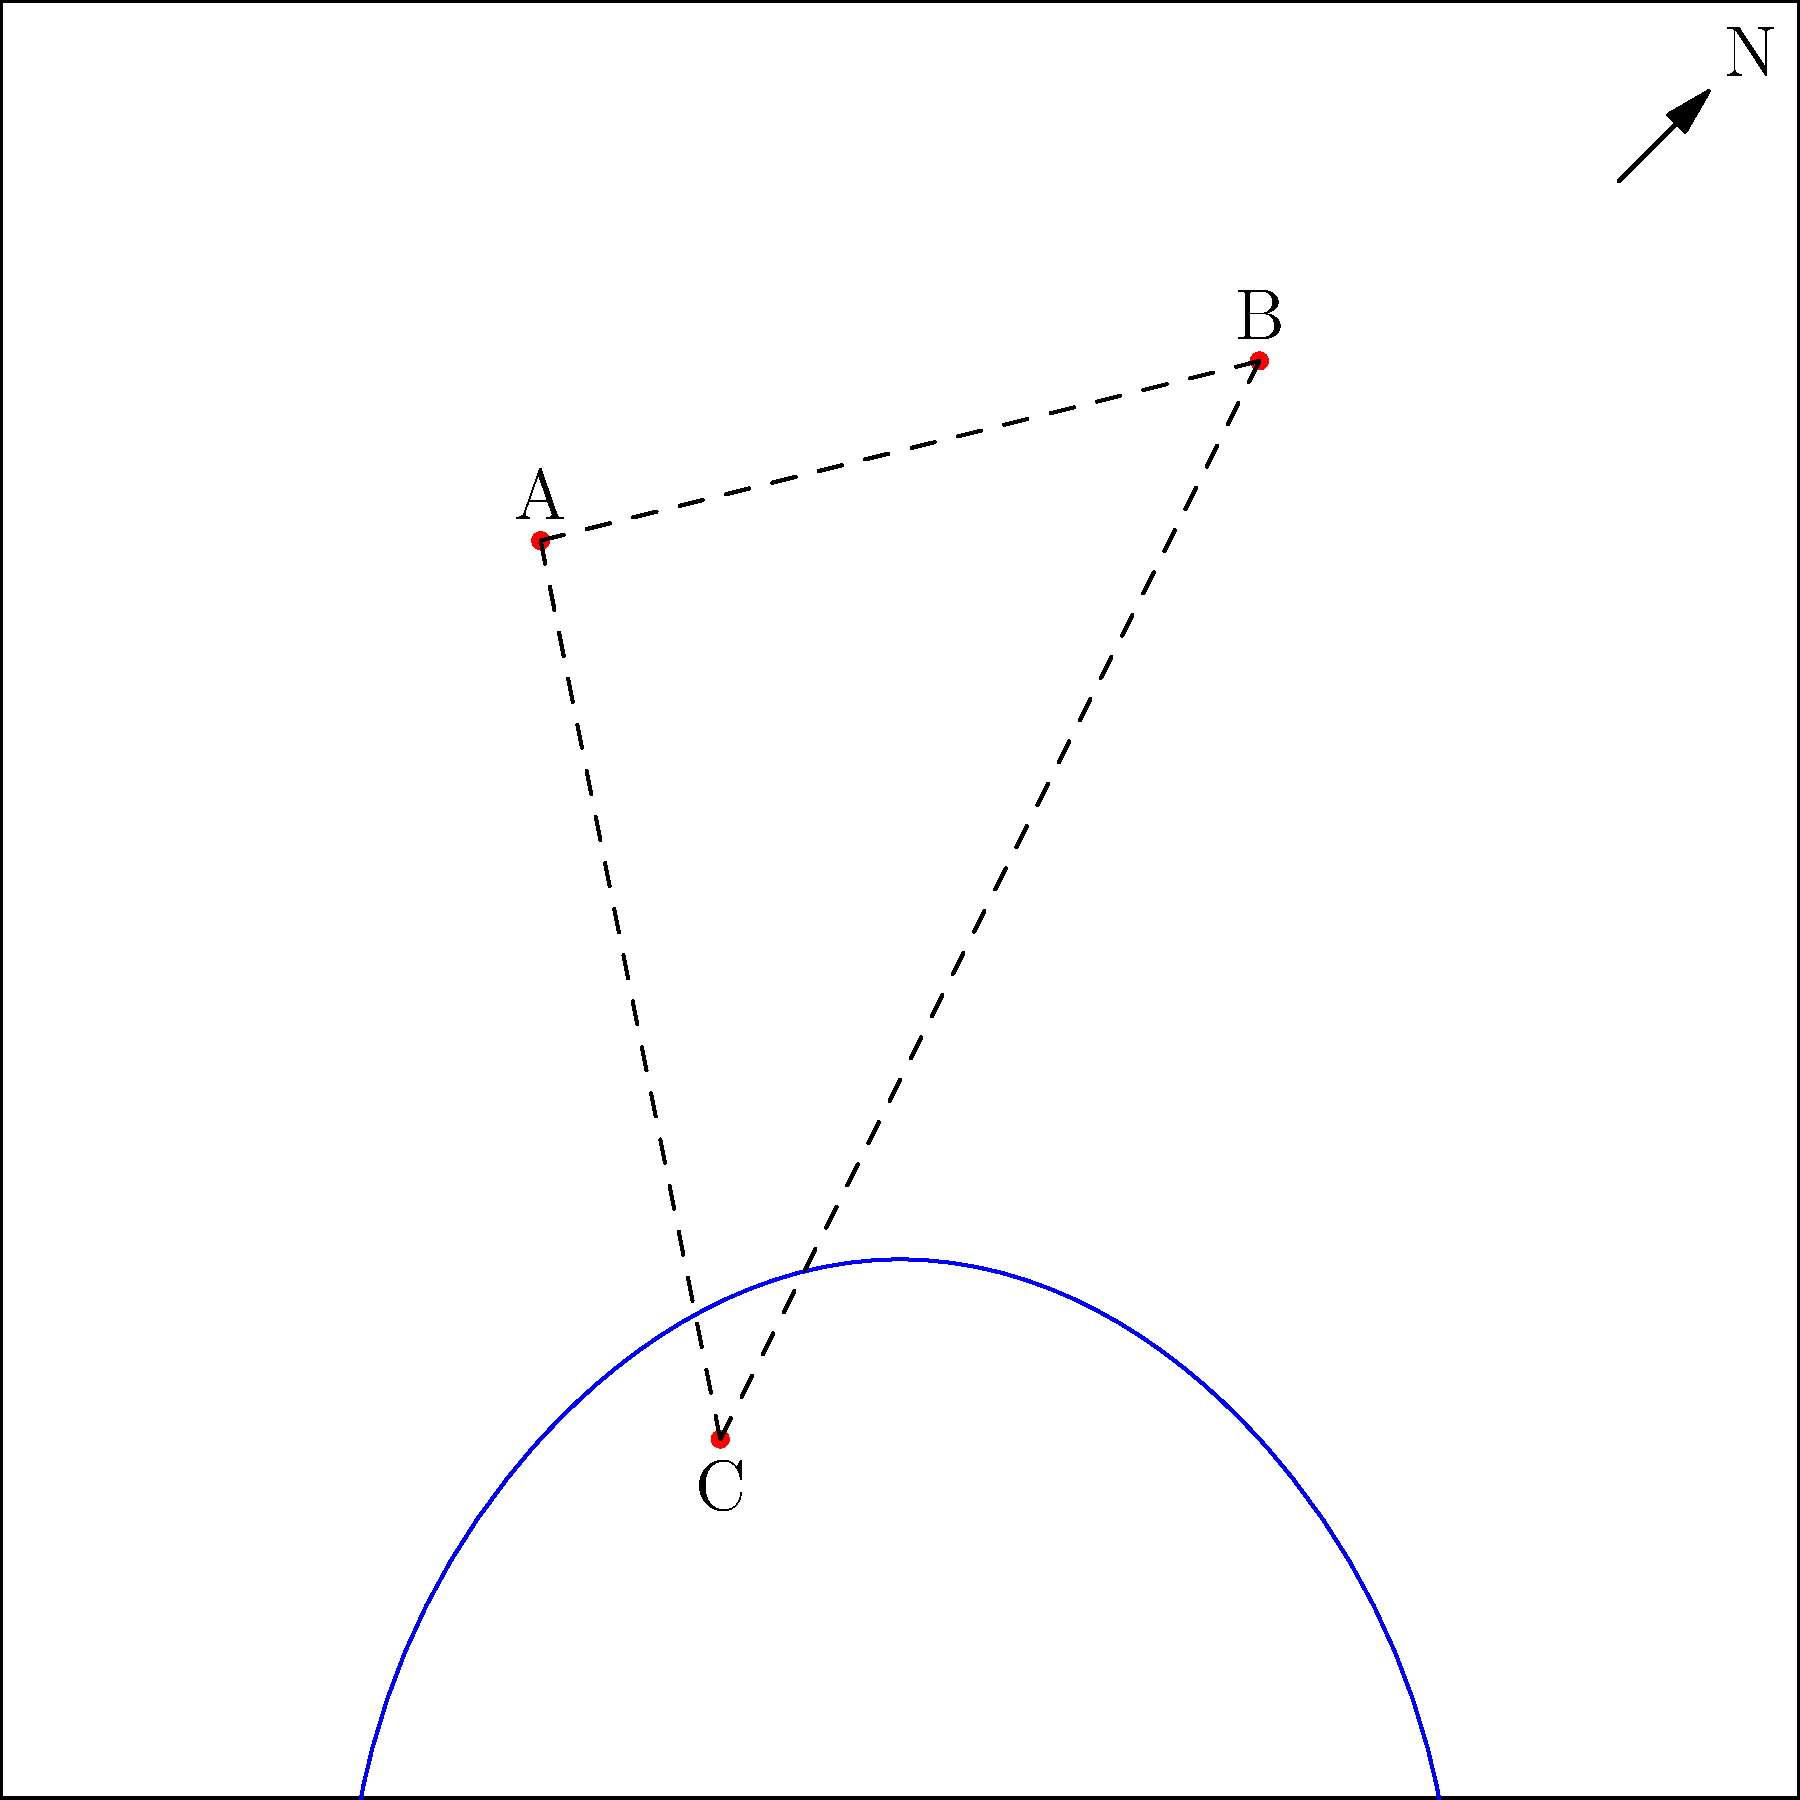Analyze the provided historical map showing three cities (A, B, and C) connected by trade routes. Based on the coastal outline and the positioning of the cities, which city was likely the most important trading hub during this period? To determine the most important trading hub, we need to consider several factors:

1. Coastal access: City C is the only one located directly on the coast, giving it an advantage for maritime trade.

2. Central location: City C is positioned between cities A and B, making it a natural meeting point for trade routes.

3. Trade route connections: All three cities are connected by trade routes, but City C acts as a central node, connecting both A and B.

4. Geographical features: The coastal area near City C appears to form a natural harbor, which would be advantageous for trade.

5. Historical context: In many historical periods, coastal cities with good harbor facilities often became important trading hubs due to their ability to facilitate both land and sea trade.

Given these factors, City C emerges as the most likely candidate for the most important trading hub. Its coastal location, central position between the other two cities, and potential harbor facilities would have made it a crucial point for both maritime and overland trade in this region.
Answer: City C 